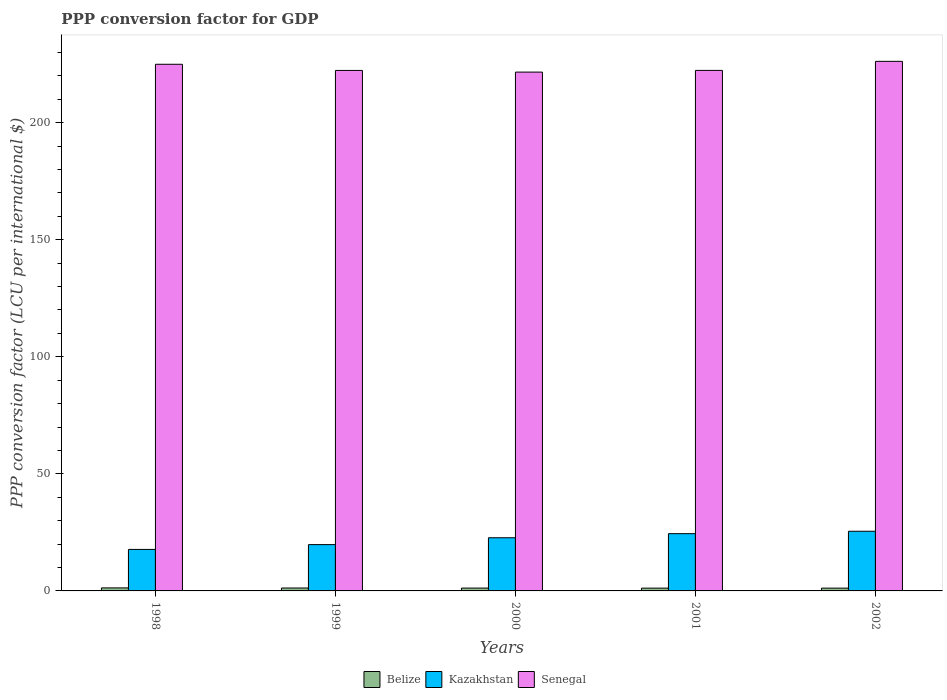How many groups of bars are there?
Keep it short and to the point. 5. Are the number of bars per tick equal to the number of legend labels?
Provide a succinct answer. Yes. Are the number of bars on each tick of the X-axis equal?
Your response must be concise. Yes. How many bars are there on the 3rd tick from the left?
Your answer should be very brief. 3. What is the label of the 1st group of bars from the left?
Make the answer very short. 1998. What is the PPP conversion factor for GDP in Belize in 2001?
Provide a short and direct response. 1.19. Across all years, what is the maximum PPP conversion factor for GDP in Kazakhstan?
Make the answer very short. 25.48. Across all years, what is the minimum PPP conversion factor for GDP in Kazakhstan?
Offer a very short reply. 17.72. In which year was the PPP conversion factor for GDP in Senegal maximum?
Ensure brevity in your answer.  2002. In which year was the PPP conversion factor for GDP in Kazakhstan minimum?
Offer a terse response. 1998. What is the total PPP conversion factor for GDP in Kazakhstan in the graph?
Provide a succinct answer. 110.14. What is the difference between the PPP conversion factor for GDP in Kazakhstan in 1998 and that in 2002?
Your answer should be very brief. -7.76. What is the difference between the PPP conversion factor for GDP in Belize in 2002 and the PPP conversion factor for GDP in Senegal in 1999?
Keep it short and to the point. -221.09. What is the average PPP conversion factor for GDP in Belize per year?
Keep it short and to the point. 1.23. In the year 2000, what is the difference between the PPP conversion factor for GDP in Belize and PPP conversion factor for GDP in Kazakhstan?
Keep it short and to the point. -21.49. What is the ratio of the PPP conversion factor for GDP in Senegal in 2000 to that in 2001?
Offer a very short reply. 1. Is the difference between the PPP conversion factor for GDP in Belize in 1999 and 2001 greater than the difference between the PPP conversion factor for GDP in Kazakhstan in 1999 and 2001?
Offer a terse response. Yes. What is the difference between the highest and the second highest PPP conversion factor for GDP in Kazakhstan?
Your response must be concise. 1.03. What is the difference between the highest and the lowest PPP conversion factor for GDP in Kazakhstan?
Offer a very short reply. 7.76. Is the sum of the PPP conversion factor for GDP in Kazakhstan in 2000 and 2001 greater than the maximum PPP conversion factor for GDP in Senegal across all years?
Your answer should be very brief. No. What does the 1st bar from the left in 2002 represents?
Give a very brief answer. Belize. What does the 3rd bar from the right in 2001 represents?
Ensure brevity in your answer.  Belize. Is it the case that in every year, the sum of the PPP conversion factor for GDP in Belize and PPP conversion factor for GDP in Kazakhstan is greater than the PPP conversion factor for GDP in Senegal?
Ensure brevity in your answer.  No. What is the difference between two consecutive major ticks on the Y-axis?
Your response must be concise. 50. Are the values on the major ticks of Y-axis written in scientific E-notation?
Offer a terse response. No. Does the graph contain any zero values?
Your response must be concise. No. Where does the legend appear in the graph?
Offer a very short reply. Bottom center. How are the legend labels stacked?
Ensure brevity in your answer.  Horizontal. What is the title of the graph?
Your response must be concise. PPP conversion factor for GDP. What is the label or title of the Y-axis?
Provide a short and direct response. PPP conversion factor (LCU per international $). What is the PPP conversion factor (LCU per international $) in Belize in 1998?
Offer a terse response. 1.29. What is the PPP conversion factor (LCU per international $) of Kazakhstan in 1998?
Ensure brevity in your answer.  17.72. What is the PPP conversion factor (LCU per international $) of Senegal in 1998?
Your response must be concise. 224.92. What is the PPP conversion factor (LCU per international $) in Belize in 1999?
Make the answer very short. 1.24. What is the PPP conversion factor (LCU per international $) of Kazakhstan in 1999?
Provide a short and direct response. 19.78. What is the PPP conversion factor (LCU per international $) in Senegal in 1999?
Your answer should be very brief. 222.29. What is the PPP conversion factor (LCU per international $) in Belize in 2000?
Provide a short and direct response. 1.22. What is the PPP conversion factor (LCU per international $) of Kazakhstan in 2000?
Your answer should be very brief. 22.71. What is the PPP conversion factor (LCU per international $) in Senegal in 2000?
Offer a very short reply. 221.57. What is the PPP conversion factor (LCU per international $) of Belize in 2001?
Keep it short and to the point. 1.19. What is the PPP conversion factor (LCU per international $) in Kazakhstan in 2001?
Your answer should be compact. 24.45. What is the PPP conversion factor (LCU per international $) in Senegal in 2001?
Your answer should be compact. 222.3. What is the PPP conversion factor (LCU per international $) of Belize in 2002?
Give a very brief answer. 1.19. What is the PPP conversion factor (LCU per international $) in Kazakhstan in 2002?
Give a very brief answer. 25.48. What is the PPP conversion factor (LCU per international $) in Senegal in 2002?
Offer a very short reply. 226.16. Across all years, what is the maximum PPP conversion factor (LCU per international $) in Belize?
Your response must be concise. 1.29. Across all years, what is the maximum PPP conversion factor (LCU per international $) of Kazakhstan?
Your response must be concise. 25.48. Across all years, what is the maximum PPP conversion factor (LCU per international $) of Senegal?
Give a very brief answer. 226.16. Across all years, what is the minimum PPP conversion factor (LCU per international $) in Belize?
Give a very brief answer. 1.19. Across all years, what is the minimum PPP conversion factor (LCU per international $) of Kazakhstan?
Make the answer very short. 17.72. Across all years, what is the minimum PPP conversion factor (LCU per international $) in Senegal?
Your answer should be compact. 221.57. What is the total PPP conversion factor (LCU per international $) in Belize in the graph?
Provide a succinct answer. 6.13. What is the total PPP conversion factor (LCU per international $) in Kazakhstan in the graph?
Offer a very short reply. 110.14. What is the total PPP conversion factor (LCU per international $) of Senegal in the graph?
Keep it short and to the point. 1117.24. What is the difference between the PPP conversion factor (LCU per international $) of Belize in 1998 and that in 1999?
Make the answer very short. 0.05. What is the difference between the PPP conversion factor (LCU per international $) in Kazakhstan in 1998 and that in 1999?
Your response must be concise. -2.05. What is the difference between the PPP conversion factor (LCU per international $) in Senegal in 1998 and that in 1999?
Provide a short and direct response. 2.63. What is the difference between the PPP conversion factor (LCU per international $) in Belize in 1998 and that in 2000?
Your response must be concise. 0.07. What is the difference between the PPP conversion factor (LCU per international $) of Kazakhstan in 1998 and that in 2000?
Offer a terse response. -4.98. What is the difference between the PPP conversion factor (LCU per international $) in Senegal in 1998 and that in 2000?
Your answer should be very brief. 3.35. What is the difference between the PPP conversion factor (LCU per international $) in Belize in 1998 and that in 2001?
Offer a terse response. 0.1. What is the difference between the PPP conversion factor (LCU per international $) in Kazakhstan in 1998 and that in 2001?
Your response must be concise. -6.73. What is the difference between the PPP conversion factor (LCU per international $) of Senegal in 1998 and that in 2001?
Keep it short and to the point. 2.62. What is the difference between the PPP conversion factor (LCU per international $) in Belize in 1998 and that in 2002?
Offer a very short reply. 0.1. What is the difference between the PPP conversion factor (LCU per international $) of Kazakhstan in 1998 and that in 2002?
Make the answer very short. -7.76. What is the difference between the PPP conversion factor (LCU per international $) of Senegal in 1998 and that in 2002?
Your answer should be very brief. -1.24. What is the difference between the PPP conversion factor (LCU per international $) in Belize in 1999 and that in 2000?
Offer a terse response. 0.02. What is the difference between the PPP conversion factor (LCU per international $) of Kazakhstan in 1999 and that in 2000?
Your response must be concise. -2.93. What is the difference between the PPP conversion factor (LCU per international $) in Senegal in 1999 and that in 2000?
Keep it short and to the point. 0.71. What is the difference between the PPP conversion factor (LCU per international $) of Belize in 1999 and that in 2001?
Provide a short and direct response. 0.05. What is the difference between the PPP conversion factor (LCU per international $) in Kazakhstan in 1999 and that in 2001?
Make the answer very short. -4.68. What is the difference between the PPP conversion factor (LCU per international $) of Senegal in 1999 and that in 2001?
Make the answer very short. -0.01. What is the difference between the PPP conversion factor (LCU per international $) of Belize in 1999 and that in 2002?
Offer a very short reply. 0.05. What is the difference between the PPP conversion factor (LCU per international $) in Kazakhstan in 1999 and that in 2002?
Your response must be concise. -5.71. What is the difference between the PPP conversion factor (LCU per international $) in Senegal in 1999 and that in 2002?
Give a very brief answer. -3.88. What is the difference between the PPP conversion factor (LCU per international $) of Belize in 2000 and that in 2001?
Provide a succinct answer. 0.03. What is the difference between the PPP conversion factor (LCU per international $) of Kazakhstan in 2000 and that in 2001?
Offer a terse response. -1.75. What is the difference between the PPP conversion factor (LCU per international $) of Senegal in 2000 and that in 2001?
Give a very brief answer. -0.73. What is the difference between the PPP conversion factor (LCU per international $) of Belize in 2000 and that in 2002?
Your response must be concise. 0.03. What is the difference between the PPP conversion factor (LCU per international $) of Kazakhstan in 2000 and that in 2002?
Give a very brief answer. -2.78. What is the difference between the PPP conversion factor (LCU per international $) of Senegal in 2000 and that in 2002?
Keep it short and to the point. -4.59. What is the difference between the PPP conversion factor (LCU per international $) in Belize in 2001 and that in 2002?
Keep it short and to the point. -0. What is the difference between the PPP conversion factor (LCU per international $) of Kazakhstan in 2001 and that in 2002?
Offer a terse response. -1.03. What is the difference between the PPP conversion factor (LCU per international $) in Senegal in 2001 and that in 2002?
Your answer should be compact. -3.86. What is the difference between the PPP conversion factor (LCU per international $) of Belize in 1998 and the PPP conversion factor (LCU per international $) of Kazakhstan in 1999?
Your answer should be very brief. -18.49. What is the difference between the PPP conversion factor (LCU per international $) in Belize in 1998 and the PPP conversion factor (LCU per international $) in Senegal in 1999?
Ensure brevity in your answer.  -221. What is the difference between the PPP conversion factor (LCU per international $) in Kazakhstan in 1998 and the PPP conversion factor (LCU per international $) in Senegal in 1999?
Provide a short and direct response. -204.56. What is the difference between the PPP conversion factor (LCU per international $) of Belize in 1998 and the PPP conversion factor (LCU per international $) of Kazakhstan in 2000?
Your answer should be compact. -21.42. What is the difference between the PPP conversion factor (LCU per international $) of Belize in 1998 and the PPP conversion factor (LCU per international $) of Senegal in 2000?
Your answer should be compact. -220.28. What is the difference between the PPP conversion factor (LCU per international $) of Kazakhstan in 1998 and the PPP conversion factor (LCU per international $) of Senegal in 2000?
Offer a terse response. -203.85. What is the difference between the PPP conversion factor (LCU per international $) of Belize in 1998 and the PPP conversion factor (LCU per international $) of Kazakhstan in 2001?
Provide a succinct answer. -23.17. What is the difference between the PPP conversion factor (LCU per international $) of Belize in 1998 and the PPP conversion factor (LCU per international $) of Senegal in 2001?
Give a very brief answer. -221.01. What is the difference between the PPP conversion factor (LCU per international $) of Kazakhstan in 1998 and the PPP conversion factor (LCU per international $) of Senegal in 2001?
Your response must be concise. -204.57. What is the difference between the PPP conversion factor (LCU per international $) of Belize in 1998 and the PPP conversion factor (LCU per international $) of Kazakhstan in 2002?
Provide a succinct answer. -24.19. What is the difference between the PPP conversion factor (LCU per international $) of Belize in 1998 and the PPP conversion factor (LCU per international $) of Senegal in 2002?
Ensure brevity in your answer.  -224.87. What is the difference between the PPP conversion factor (LCU per international $) of Kazakhstan in 1998 and the PPP conversion factor (LCU per international $) of Senegal in 2002?
Your answer should be very brief. -208.44. What is the difference between the PPP conversion factor (LCU per international $) in Belize in 1999 and the PPP conversion factor (LCU per international $) in Kazakhstan in 2000?
Give a very brief answer. -21.46. What is the difference between the PPP conversion factor (LCU per international $) in Belize in 1999 and the PPP conversion factor (LCU per international $) in Senegal in 2000?
Give a very brief answer. -220.33. What is the difference between the PPP conversion factor (LCU per international $) in Kazakhstan in 1999 and the PPP conversion factor (LCU per international $) in Senegal in 2000?
Give a very brief answer. -201.8. What is the difference between the PPP conversion factor (LCU per international $) of Belize in 1999 and the PPP conversion factor (LCU per international $) of Kazakhstan in 2001?
Your answer should be very brief. -23.21. What is the difference between the PPP conversion factor (LCU per international $) in Belize in 1999 and the PPP conversion factor (LCU per international $) in Senegal in 2001?
Provide a succinct answer. -221.06. What is the difference between the PPP conversion factor (LCU per international $) of Kazakhstan in 1999 and the PPP conversion factor (LCU per international $) of Senegal in 2001?
Offer a very short reply. -202.52. What is the difference between the PPP conversion factor (LCU per international $) in Belize in 1999 and the PPP conversion factor (LCU per international $) in Kazakhstan in 2002?
Provide a short and direct response. -24.24. What is the difference between the PPP conversion factor (LCU per international $) of Belize in 1999 and the PPP conversion factor (LCU per international $) of Senegal in 2002?
Provide a succinct answer. -224.92. What is the difference between the PPP conversion factor (LCU per international $) in Kazakhstan in 1999 and the PPP conversion factor (LCU per international $) in Senegal in 2002?
Ensure brevity in your answer.  -206.39. What is the difference between the PPP conversion factor (LCU per international $) in Belize in 2000 and the PPP conversion factor (LCU per international $) in Kazakhstan in 2001?
Your answer should be very brief. -23.23. What is the difference between the PPP conversion factor (LCU per international $) of Belize in 2000 and the PPP conversion factor (LCU per international $) of Senegal in 2001?
Give a very brief answer. -221.08. What is the difference between the PPP conversion factor (LCU per international $) of Kazakhstan in 2000 and the PPP conversion factor (LCU per international $) of Senegal in 2001?
Make the answer very short. -199.59. What is the difference between the PPP conversion factor (LCU per international $) of Belize in 2000 and the PPP conversion factor (LCU per international $) of Kazakhstan in 2002?
Your response must be concise. -24.26. What is the difference between the PPP conversion factor (LCU per international $) of Belize in 2000 and the PPP conversion factor (LCU per international $) of Senegal in 2002?
Give a very brief answer. -224.94. What is the difference between the PPP conversion factor (LCU per international $) of Kazakhstan in 2000 and the PPP conversion factor (LCU per international $) of Senegal in 2002?
Keep it short and to the point. -203.46. What is the difference between the PPP conversion factor (LCU per international $) of Belize in 2001 and the PPP conversion factor (LCU per international $) of Kazakhstan in 2002?
Keep it short and to the point. -24.29. What is the difference between the PPP conversion factor (LCU per international $) in Belize in 2001 and the PPP conversion factor (LCU per international $) in Senegal in 2002?
Offer a very short reply. -224.97. What is the difference between the PPP conversion factor (LCU per international $) of Kazakhstan in 2001 and the PPP conversion factor (LCU per international $) of Senegal in 2002?
Provide a succinct answer. -201.71. What is the average PPP conversion factor (LCU per international $) of Belize per year?
Ensure brevity in your answer.  1.23. What is the average PPP conversion factor (LCU per international $) in Kazakhstan per year?
Ensure brevity in your answer.  22.03. What is the average PPP conversion factor (LCU per international $) in Senegal per year?
Provide a short and direct response. 223.45. In the year 1998, what is the difference between the PPP conversion factor (LCU per international $) in Belize and PPP conversion factor (LCU per international $) in Kazakhstan?
Make the answer very short. -16.44. In the year 1998, what is the difference between the PPP conversion factor (LCU per international $) of Belize and PPP conversion factor (LCU per international $) of Senegal?
Offer a terse response. -223.63. In the year 1998, what is the difference between the PPP conversion factor (LCU per international $) in Kazakhstan and PPP conversion factor (LCU per international $) in Senegal?
Keep it short and to the point. -207.19. In the year 1999, what is the difference between the PPP conversion factor (LCU per international $) of Belize and PPP conversion factor (LCU per international $) of Kazakhstan?
Ensure brevity in your answer.  -18.53. In the year 1999, what is the difference between the PPP conversion factor (LCU per international $) of Belize and PPP conversion factor (LCU per international $) of Senegal?
Provide a succinct answer. -221.04. In the year 1999, what is the difference between the PPP conversion factor (LCU per international $) of Kazakhstan and PPP conversion factor (LCU per international $) of Senegal?
Provide a succinct answer. -202.51. In the year 2000, what is the difference between the PPP conversion factor (LCU per international $) in Belize and PPP conversion factor (LCU per international $) in Kazakhstan?
Make the answer very short. -21.49. In the year 2000, what is the difference between the PPP conversion factor (LCU per international $) in Belize and PPP conversion factor (LCU per international $) in Senegal?
Keep it short and to the point. -220.35. In the year 2000, what is the difference between the PPP conversion factor (LCU per international $) in Kazakhstan and PPP conversion factor (LCU per international $) in Senegal?
Your answer should be compact. -198.87. In the year 2001, what is the difference between the PPP conversion factor (LCU per international $) in Belize and PPP conversion factor (LCU per international $) in Kazakhstan?
Keep it short and to the point. -23.26. In the year 2001, what is the difference between the PPP conversion factor (LCU per international $) of Belize and PPP conversion factor (LCU per international $) of Senegal?
Give a very brief answer. -221.11. In the year 2001, what is the difference between the PPP conversion factor (LCU per international $) in Kazakhstan and PPP conversion factor (LCU per international $) in Senegal?
Your answer should be very brief. -197.84. In the year 2002, what is the difference between the PPP conversion factor (LCU per international $) of Belize and PPP conversion factor (LCU per international $) of Kazakhstan?
Provide a succinct answer. -24.29. In the year 2002, what is the difference between the PPP conversion factor (LCU per international $) of Belize and PPP conversion factor (LCU per international $) of Senegal?
Your answer should be very brief. -224.97. In the year 2002, what is the difference between the PPP conversion factor (LCU per international $) of Kazakhstan and PPP conversion factor (LCU per international $) of Senegal?
Your answer should be compact. -200.68. What is the ratio of the PPP conversion factor (LCU per international $) in Kazakhstan in 1998 to that in 1999?
Offer a very short reply. 0.9. What is the ratio of the PPP conversion factor (LCU per international $) of Senegal in 1998 to that in 1999?
Your response must be concise. 1.01. What is the ratio of the PPP conversion factor (LCU per international $) of Belize in 1998 to that in 2000?
Ensure brevity in your answer.  1.06. What is the ratio of the PPP conversion factor (LCU per international $) of Kazakhstan in 1998 to that in 2000?
Offer a very short reply. 0.78. What is the ratio of the PPP conversion factor (LCU per international $) in Senegal in 1998 to that in 2000?
Provide a succinct answer. 1.02. What is the ratio of the PPP conversion factor (LCU per international $) in Belize in 1998 to that in 2001?
Offer a terse response. 1.08. What is the ratio of the PPP conversion factor (LCU per international $) in Kazakhstan in 1998 to that in 2001?
Ensure brevity in your answer.  0.72. What is the ratio of the PPP conversion factor (LCU per international $) of Senegal in 1998 to that in 2001?
Provide a succinct answer. 1.01. What is the ratio of the PPP conversion factor (LCU per international $) in Belize in 1998 to that in 2002?
Ensure brevity in your answer.  1.08. What is the ratio of the PPP conversion factor (LCU per international $) in Kazakhstan in 1998 to that in 2002?
Offer a terse response. 0.7. What is the ratio of the PPP conversion factor (LCU per international $) of Belize in 1999 to that in 2000?
Make the answer very short. 1.02. What is the ratio of the PPP conversion factor (LCU per international $) in Kazakhstan in 1999 to that in 2000?
Provide a succinct answer. 0.87. What is the ratio of the PPP conversion factor (LCU per international $) of Belize in 1999 to that in 2001?
Keep it short and to the point. 1.04. What is the ratio of the PPP conversion factor (LCU per international $) in Kazakhstan in 1999 to that in 2001?
Your answer should be compact. 0.81. What is the ratio of the PPP conversion factor (LCU per international $) of Senegal in 1999 to that in 2001?
Provide a succinct answer. 1. What is the ratio of the PPP conversion factor (LCU per international $) in Belize in 1999 to that in 2002?
Offer a terse response. 1.04. What is the ratio of the PPP conversion factor (LCU per international $) in Kazakhstan in 1999 to that in 2002?
Keep it short and to the point. 0.78. What is the ratio of the PPP conversion factor (LCU per international $) in Senegal in 1999 to that in 2002?
Provide a short and direct response. 0.98. What is the ratio of the PPP conversion factor (LCU per international $) of Belize in 2000 to that in 2001?
Provide a succinct answer. 1.03. What is the ratio of the PPP conversion factor (LCU per international $) in Kazakhstan in 2000 to that in 2001?
Ensure brevity in your answer.  0.93. What is the ratio of the PPP conversion factor (LCU per international $) of Belize in 2000 to that in 2002?
Offer a very short reply. 1.02. What is the ratio of the PPP conversion factor (LCU per international $) in Kazakhstan in 2000 to that in 2002?
Your answer should be compact. 0.89. What is the ratio of the PPP conversion factor (LCU per international $) in Senegal in 2000 to that in 2002?
Your response must be concise. 0.98. What is the ratio of the PPP conversion factor (LCU per international $) in Belize in 2001 to that in 2002?
Provide a short and direct response. 1. What is the ratio of the PPP conversion factor (LCU per international $) of Kazakhstan in 2001 to that in 2002?
Provide a succinct answer. 0.96. What is the ratio of the PPP conversion factor (LCU per international $) in Senegal in 2001 to that in 2002?
Make the answer very short. 0.98. What is the difference between the highest and the second highest PPP conversion factor (LCU per international $) in Belize?
Your response must be concise. 0.05. What is the difference between the highest and the second highest PPP conversion factor (LCU per international $) in Kazakhstan?
Your answer should be compact. 1.03. What is the difference between the highest and the second highest PPP conversion factor (LCU per international $) of Senegal?
Offer a very short reply. 1.24. What is the difference between the highest and the lowest PPP conversion factor (LCU per international $) of Belize?
Offer a terse response. 0.1. What is the difference between the highest and the lowest PPP conversion factor (LCU per international $) in Kazakhstan?
Give a very brief answer. 7.76. What is the difference between the highest and the lowest PPP conversion factor (LCU per international $) of Senegal?
Offer a terse response. 4.59. 